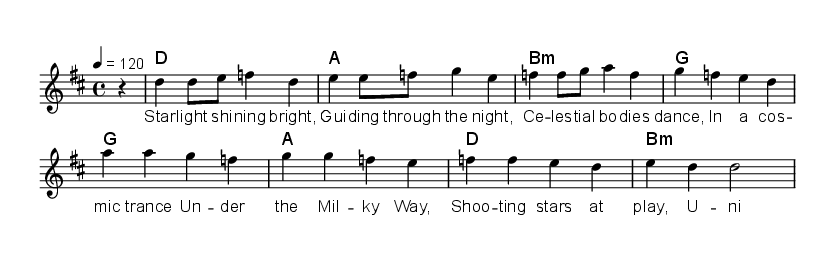What is the key signature of this music? The key signature indicated in the music is D major, which has two sharps (F# and C#). This can be identified by looking at the key signature section at the beginning of the staff.
Answer: D major What is the time signature of this music? The time signature shown in the music is 4/4, which is located at the beginning of the piece. This indicates that there are four beats per measure, and the quarter note receives one beat.
Answer: 4/4 What is the tempo marking of this music? The tempo marking reveals that the piece should be played at a speed of 120 beats per minute. This information can be found to the right of the time signature.
Answer: 120 How many measures are in the melody? By counting the distinct segments marked by vertical lines (bar lines) in the melody, we can see that there are eight measures in total.
Answer: 8 What is the first lyric in the verse? The first lyric in the verse is "Star," which is the first word of the lyric section aligned with the melody notes.
Answer: Star Which chord is used in the third measure? The chord specified in the third measure is B minor, as noted in the chord symbols above the measures indicating the harmony for this part of the song.
Answer: B minor How many distinct chords are used in total? The total number of distinct chords used in the piece can be counted from the chord mode section, where there are six unique chords as indicated.
Answer: 6 